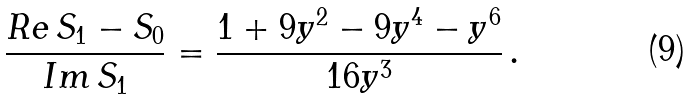<formula> <loc_0><loc_0><loc_500><loc_500>\frac { R e \, S _ { 1 } - S _ { 0 } } { I m \, S _ { 1 } } = \frac { 1 + 9 y ^ { 2 } - 9 y ^ { 4 } - y ^ { 6 } } { 1 6 y ^ { 3 } } \, .</formula> 